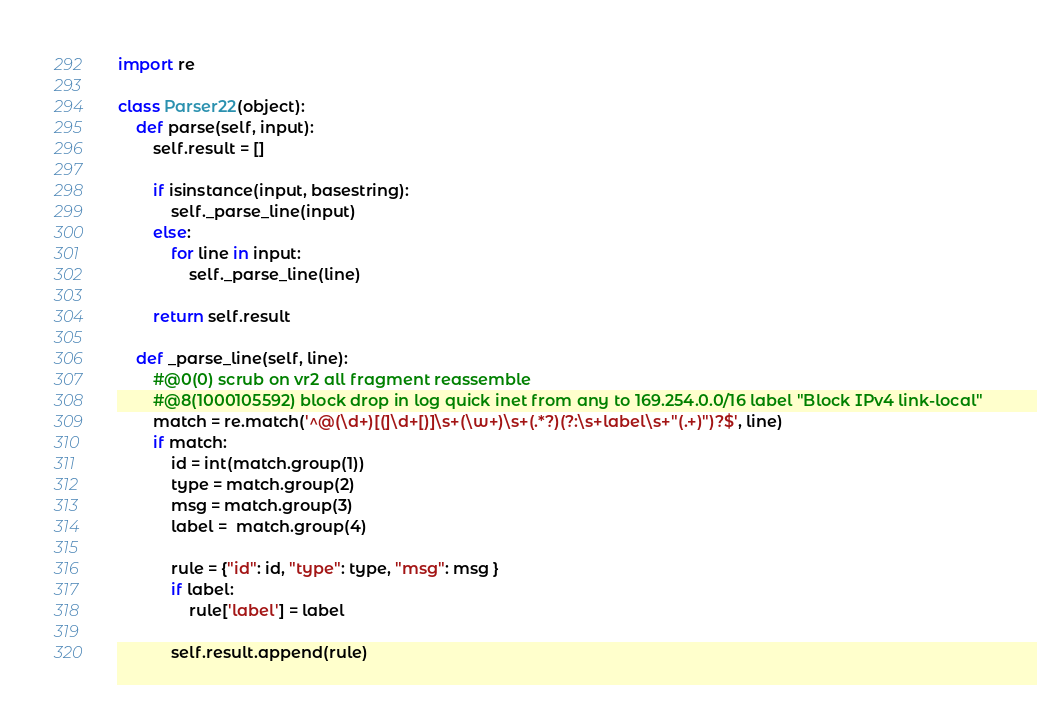Convert code to text. <code><loc_0><loc_0><loc_500><loc_500><_Python_>import re

class Parser22(object):
    def parse(self, input):
        self.result = []

        if isinstance(input, basestring):
            self._parse_line(input)
        else:
            for line in input:
                self._parse_line(line)

        return self.result

    def _parse_line(self, line):
        #@0(0) scrub on vr2 all fragment reassemble
        #@8(1000105592) block drop in log quick inet from any to 169.254.0.0/16 label "Block IPv4 link-local"
        match = re.match('^@(\d+)[(]\d+[)]\s+(\w+)\s+(.*?)(?:\s+label\s+"(.+)")?$', line)
        if match:
            id = int(match.group(1))
            type = match.group(2)
            msg = match.group(3)
            label =  match.group(4)

            rule = {"id": id, "type": type, "msg": msg }
            if label:
                rule['label'] = label

            self.result.append(rule)
</code> 